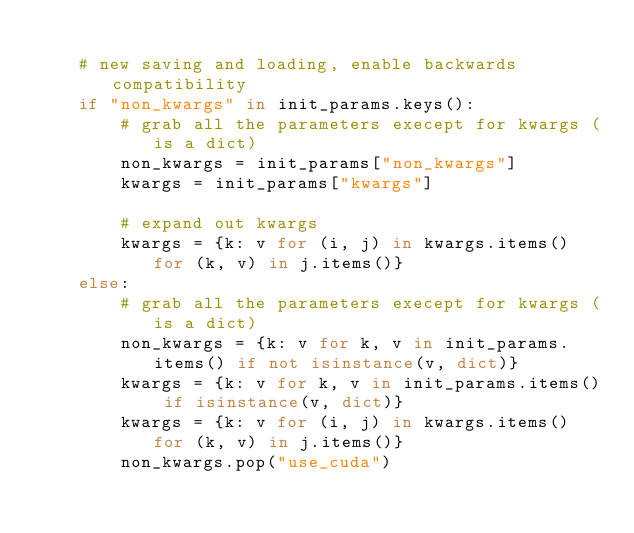Convert code to text. <code><loc_0><loc_0><loc_500><loc_500><_Python_>
    # new saving and loading, enable backwards compatibility
    if "non_kwargs" in init_params.keys():
        # grab all the parameters execept for kwargs (is a dict)
        non_kwargs = init_params["non_kwargs"]
        kwargs = init_params["kwargs"]

        # expand out kwargs
        kwargs = {k: v for (i, j) in kwargs.items() for (k, v) in j.items()}
    else:
        # grab all the parameters execept for kwargs (is a dict)
        non_kwargs = {k: v for k, v in init_params.items() if not isinstance(v, dict)}
        kwargs = {k: v for k, v in init_params.items() if isinstance(v, dict)}
        kwargs = {k: v for (i, j) in kwargs.items() for (k, v) in j.items()}
        non_kwargs.pop("use_cuda")
</code> 